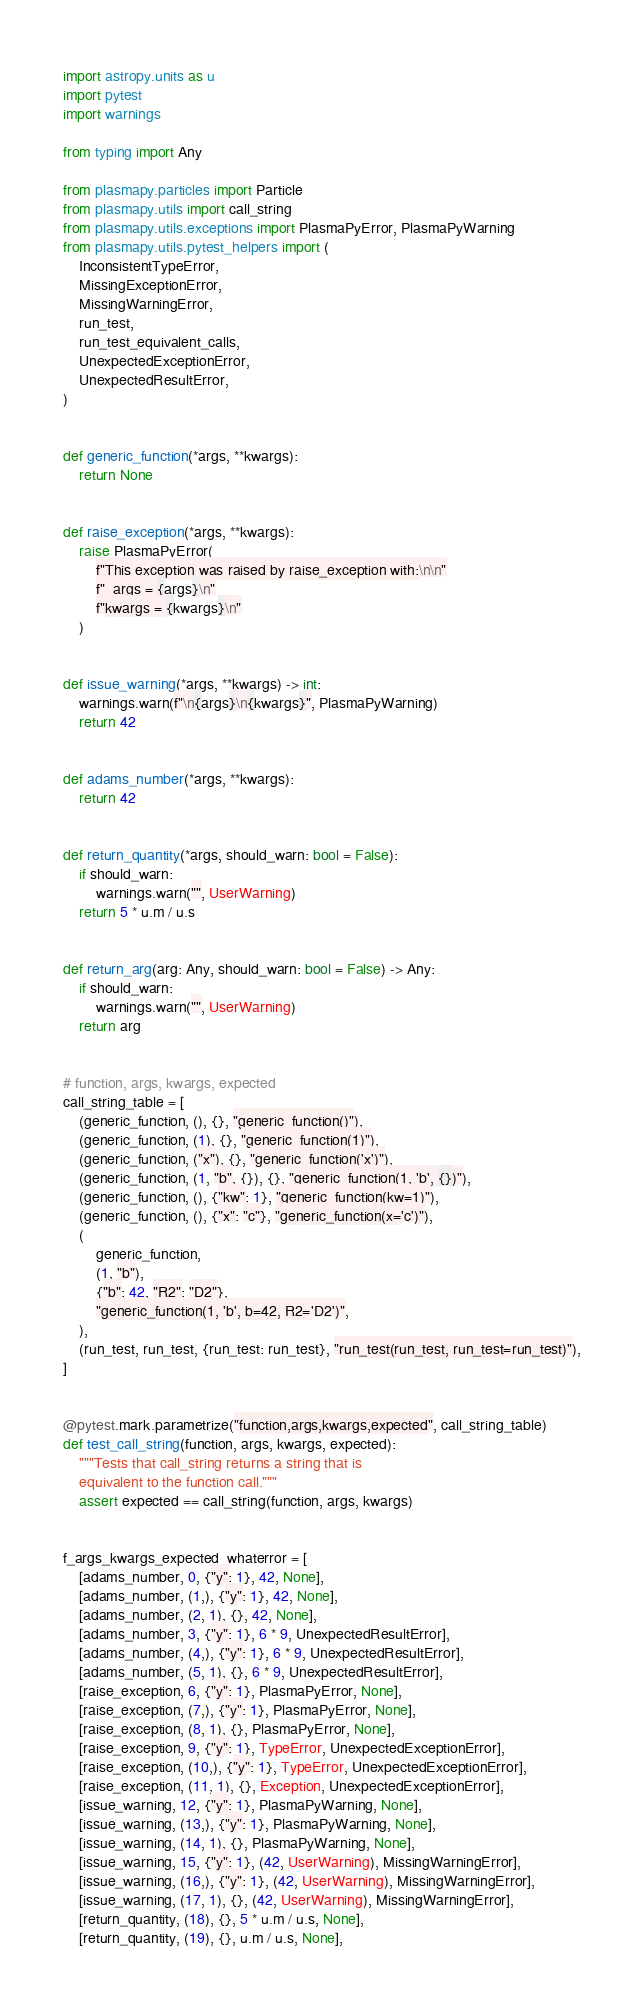Convert code to text. <code><loc_0><loc_0><loc_500><loc_500><_Python_>import astropy.units as u
import pytest
import warnings

from typing import Any

from plasmapy.particles import Particle
from plasmapy.utils import call_string
from plasmapy.utils.exceptions import PlasmaPyError, PlasmaPyWarning
from plasmapy.utils.pytest_helpers import (
    InconsistentTypeError,
    MissingExceptionError,
    MissingWarningError,
    run_test,
    run_test_equivalent_calls,
    UnexpectedExceptionError,
    UnexpectedResultError,
)


def generic_function(*args, **kwargs):
    return None


def raise_exception(*args, **kwargs):
    raise PlasmaPyError(
        f"This exception was raised by raise_exception with:\n\n"
        f"  args = {args}\n"
        f"kwargs = {kwargs}\n"
    )


def issue_warning(*args, **kwargs) -> int:
    warnings.warn(f"\n{args}\n{kwargs}", PlasmaPyWarning)
    return 42


def adams_number(*args, **kwargs):
    return 42


def return_quantity(*args, should_warn: bool = False):
    if should_warn:
        warnings.warn("", UserWarning)
    return 5 * u.m / u.s


def return_arg(arg: Any, should_warn: bool = False) -> Any:
    if should_warn:
        warnings.warn("", UserWarning)
    return arg


# function, args, kwargs, expected
call_string_table = [
    (generic_function, (), {}, "generic_function()"),
    (generic_function, (1), {}, "generic_function(1)"),
    (generic_function, ("x"), {}, "generic_function('x')"),
    (generic_function, (1, "b", {}), {}, "generic_function(1, 'b', {})"),
    (generic_function, (), {"kw": 1}, "generic_function(kw=1)"),
    (generic_function, (), {"x": "c"}, "generic_function(x='c')"),
    (
        generic_function,
        (1, "b"),
        {"b": 42, "R2": "D2"},
        "generic_function(1, 'b', b=42, R2='D2')",
    ),
    (run_test, run_test, {run_test: run_test}, "run_test(run_test, run_test=run_test)"),
]


@pytest.mark.parametrize("function,args,kwargs,expected", call_string_table)
def test_call_string(function, args, kwargs, expected):
    """Tests that call_string returns a string that is
    equivalent to the function call."""
    assert expected == call_string(function, args, kwargs)


f_args_kwargs_expected_whaterror = [
    [adams_number, 0, {"y": 1}, 42, None],
    [adams_number, (1,), {"y": 1}, 42, None],
    [adams_number, (2, 1), {}, 42, None],
    [adams_number, 3, {"y": 1}, 6 * 9, UnexpectedResultError],
    [adams_number, (4,), {"y": 1}, 6 * 9, UnexpectedResultError],
    [adams_number, (5, 1), {}, 6 * 9, UnexpectedResultError],
    [raise_exception, 6, {"y": 1}, PlasmaPyError, None],
    [raise_exception, (7,), {"y": 1}, PlasmaPyError, None],
    [raise_exception, (8, 1), {}, PlasmaPyError, None],
    [raise_exception, 9, {"y": 1}, TypeError, UnexpectedExceptionError],
    [raise_exception, (10,), {"y": 1}, TypeError, UnexpectedExceptionError],
    [raise_exception, (11, 1), {}, Exception, UnexpectedExceptionError],
    [issue_warning, 12, {"y": 1}, PlasmaPyWarning, None],
    [issue_warning, (13,), {"y": 1}, PlasmaPyWarning, None],
    [issue_warning, (14, 1), {}, PlasmaPyWarning, None],
    [issue_warning, 15, {"y": 1}, (42, UserWarning), MissingWarningError],
    [issue_warning, (16,), {"y": 1}, (42, UserWarning), MissingWarningError],
    [issue_warning, (17, 1), {}, (42, UserWarning), MissingWarningError],
    [return_quantity, (18), {}, 5 * u.m / u.s, None],
    [return_quantity, (19), {}, u.m / u.s, None],</code> 